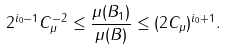Convert formula to latex. <formula><loc_0><loc_0><loc_500><loc_500>2 ^ { i _ { 0 } - 1 } C _ { \mu } ^ { - 2 } \leq \frac { \mu ( B _ { 1 } ) } { \mu ( B ) } \leq ( 2 C _ { \mu } ) ^ { i _ { 0 } + 1 } .</formula> 